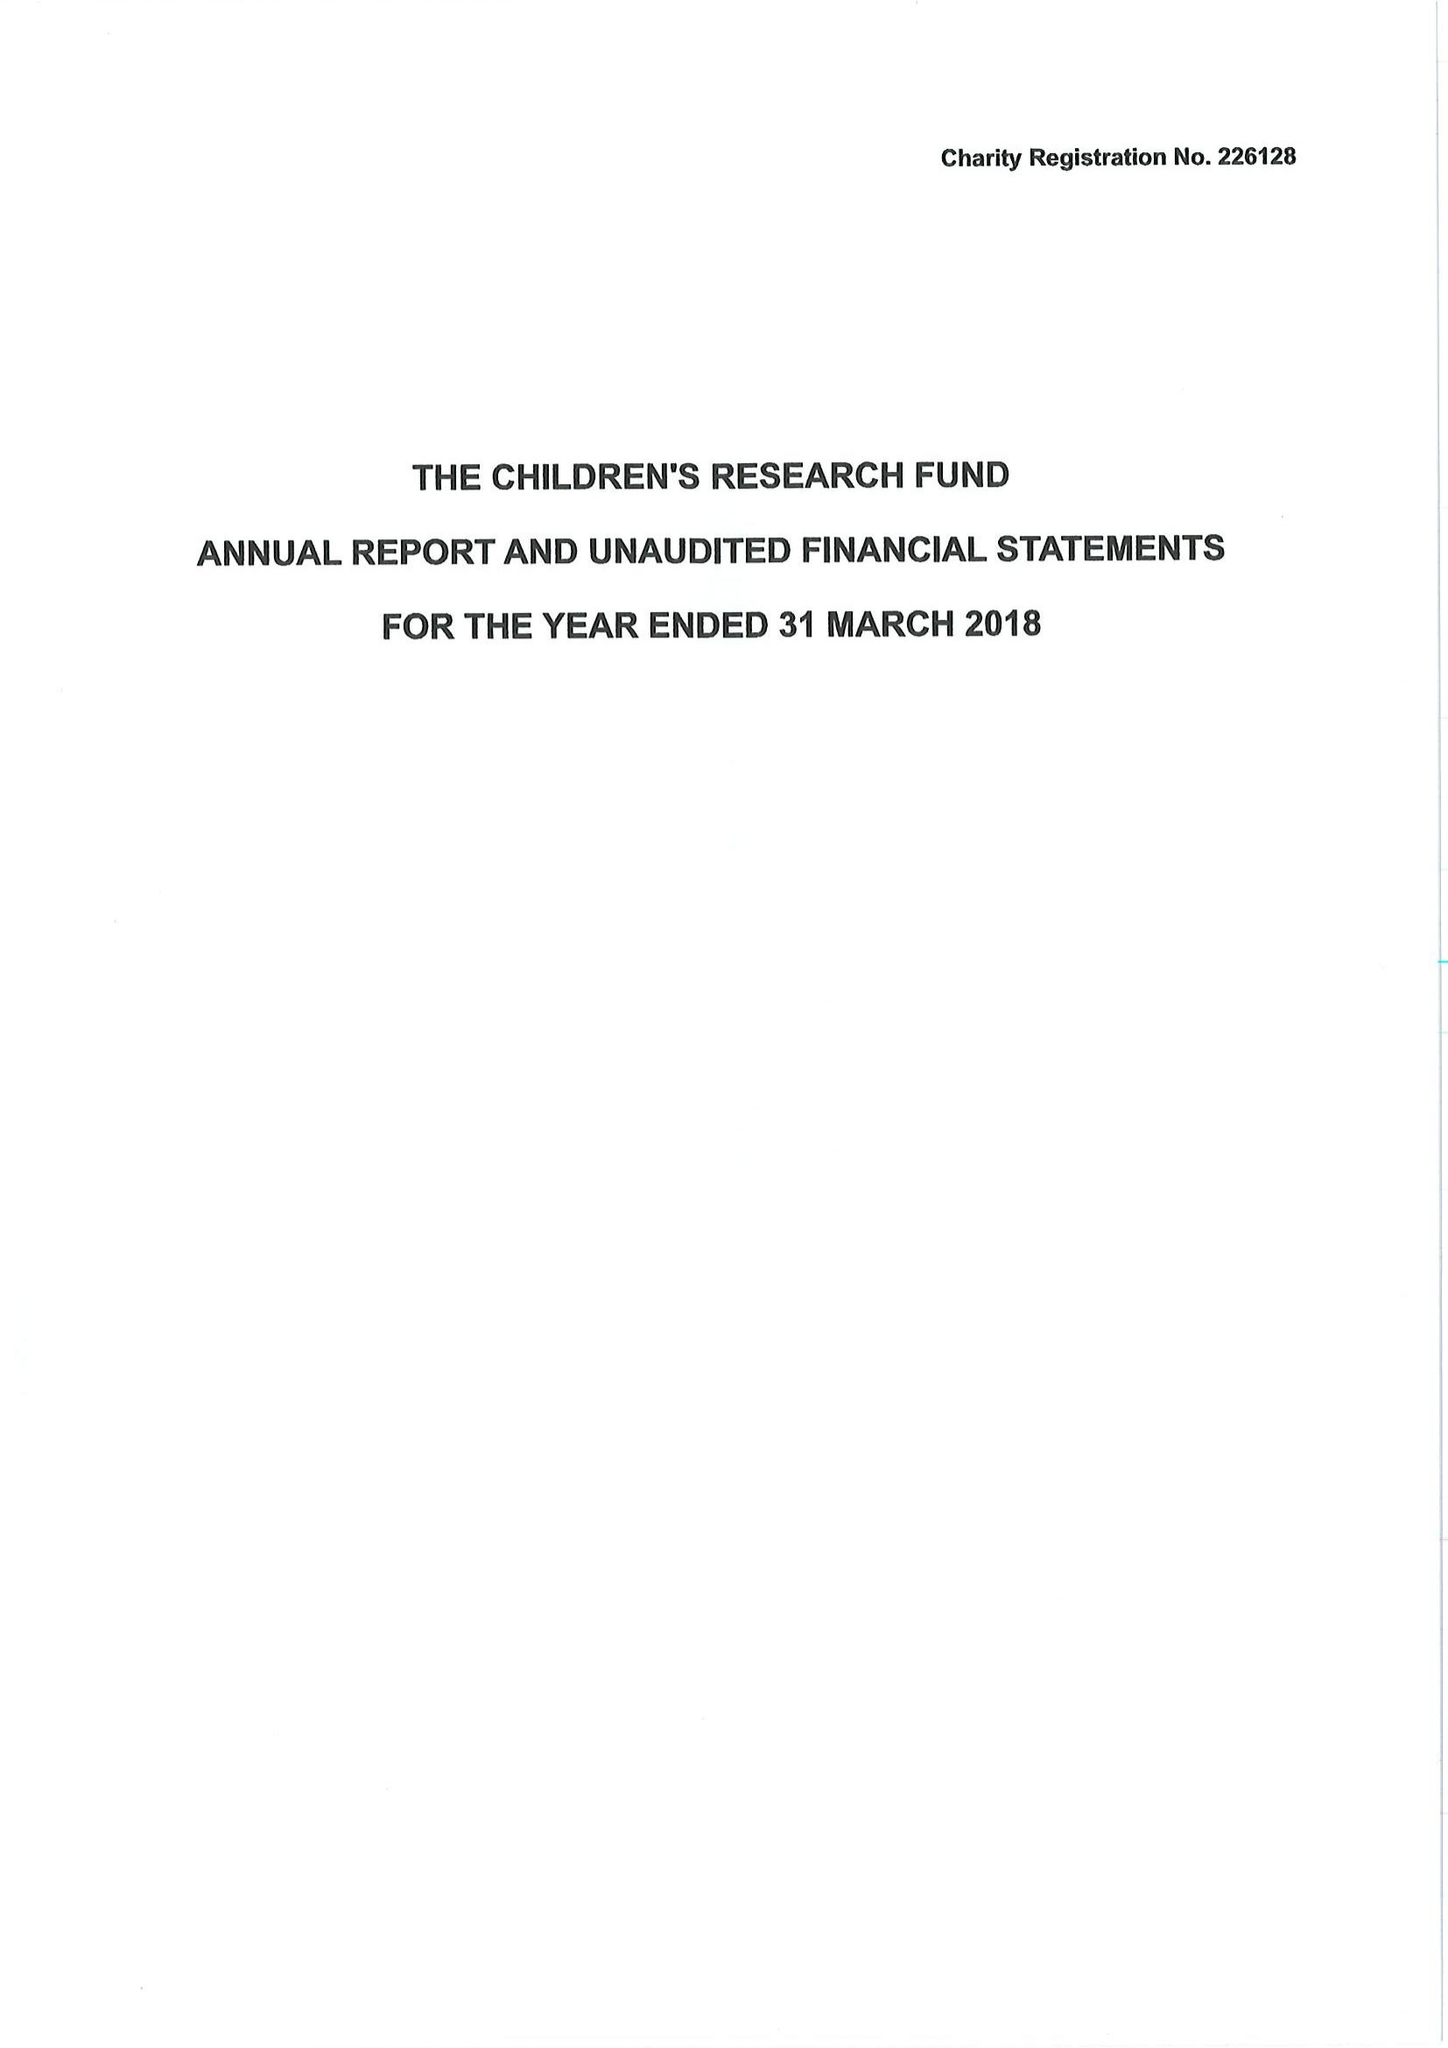What is the value for the address__street_line?
Answer the question using a single word or phrase. 14 TAN-Y-BRYN 